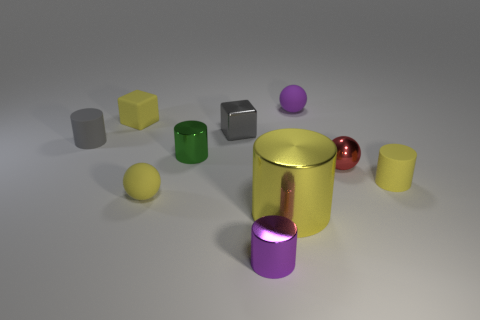What number of purple objects are either small shiny cylinders or matte balls? 2 